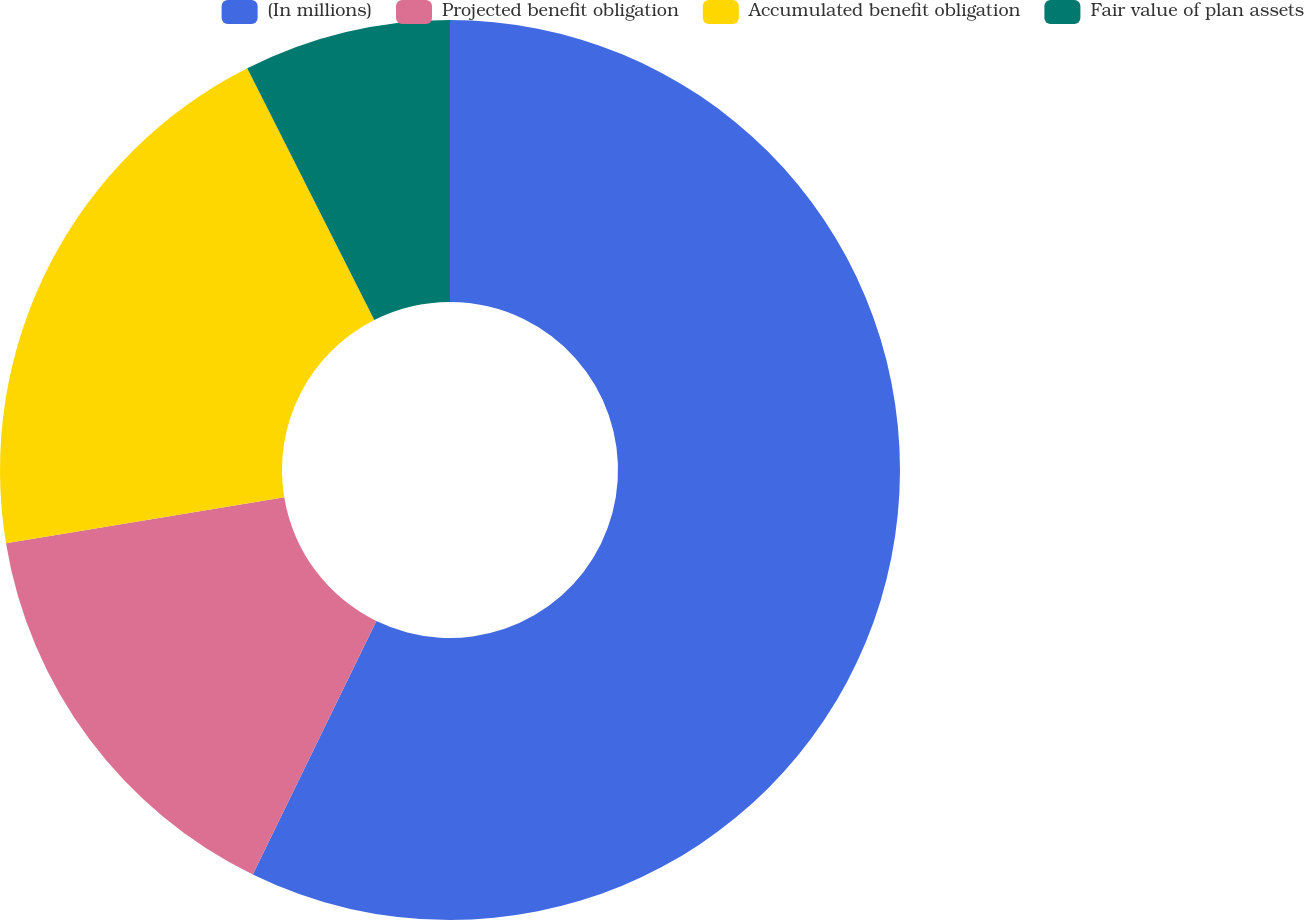Convert chart to OTSL. <chart><loc_0><loc_0><loc_500><loc_500><pie_chart><fcel>(In millions)<fcel>Projected benefit obligation<fcel>Accumulated benefit obligation<fcel>Fair value of plan assets<nl><fcel>57.22%<fcel>15.18%<fcel>20.16%<fcel>7.44%<nl></chart> 